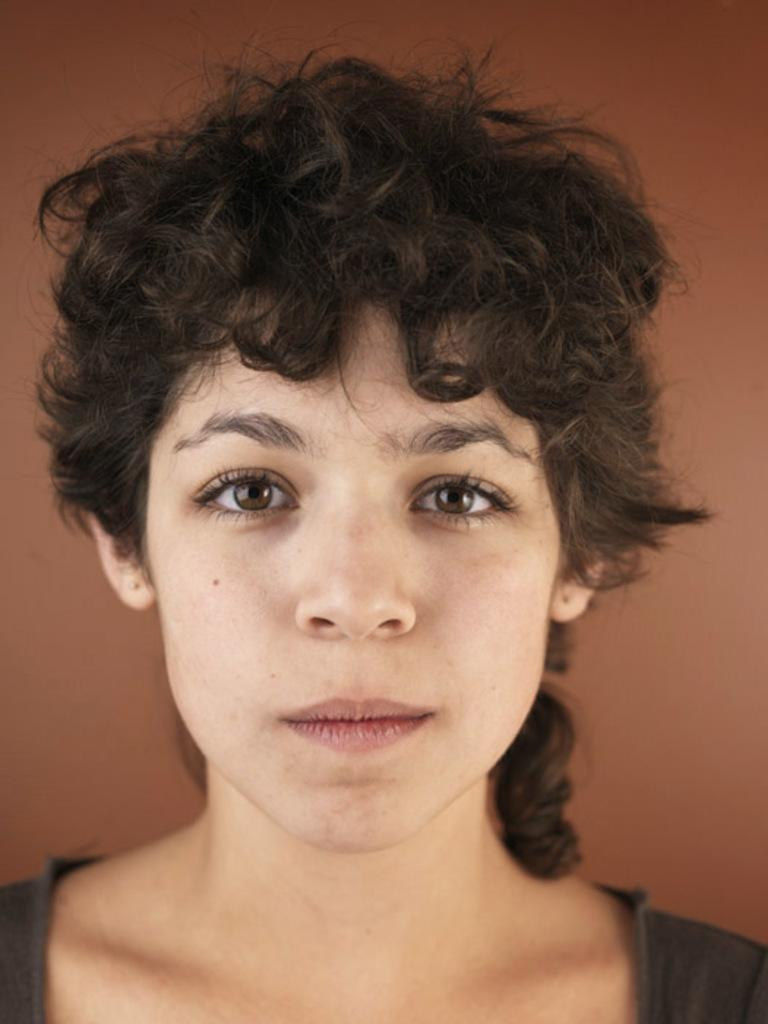Who is present in the image? There is a woman in the image. What can be seen in the background of the image? There is a wall in the background of the image. What color is the wall in the image? The wall is painted red. What language is the woman speaking in the image? The image does not provide any information about the language being spoken, as there is no audio or text present. 